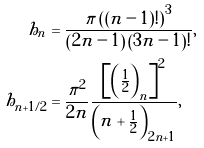<formula> <loc_0><loc_0><loc_500><loc_500>h _ { n } & = \frac { \pi \left ( \left ( n - 1 \right ) ! \right ) ^ { 3 } } { \left ( 2 n - 1 \right ) \left ( 3 n - 1 \right ) ! } , \\ h _ { n + 1 / 2 } & = \frac { \pi ^ { 2 } } { 2 n } \frac { \left [ \left ( \frac { 1 } { 2 } \right ) _ { n } \right ] ^ { 2 } } { \left ( n + \frac { 1 } { 2 } \right ) _ { 2 n + 1 } } ,</formula> 